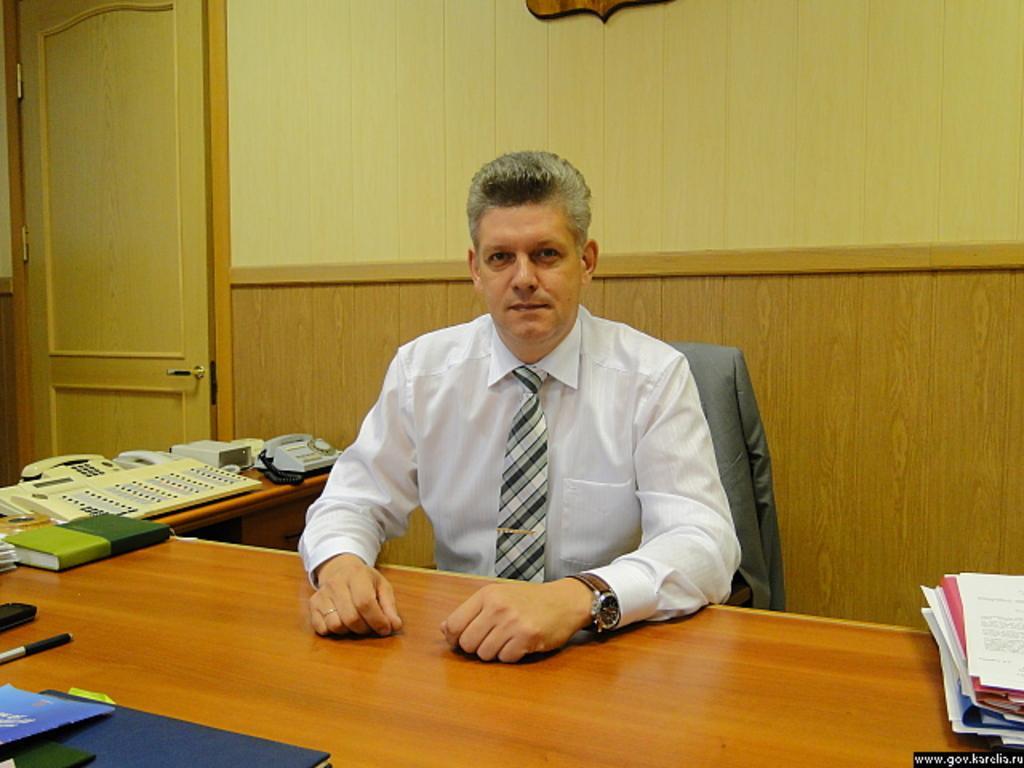Can you describe this image briefly? In the center we can see the man sitting on the chair. In front of him we can see the table,on table we can see book,phone,pen etc. Coming to the background we can see the wall and door. 